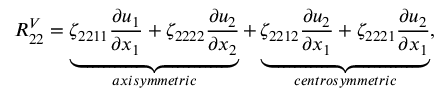Convert formula to latex. <formula><loc_0><loc_0><loc_500><loc_500>R _ { 2 2 } ^ { V } = \underbrace { \zeta _ { 2 2 1 1 } \frac { \partial u _ { 1 } } { \partial x _ { 1 } } + \zeta _ { 2 2 2 2 } \frac { \partial u _ { 2 } } { \partial x _ { 2 } } } _ { a x i s y m m e t r i c } + \underbrace { \zeta _ { 2 2 1 2 } \frac { \partial u _ { 2 } } { \partial x _ { 1 } } + \zeta _ { 2 2 2 1 } \frac { \partial u _ { 2 } } { \partial x _ { 1 } } } _ { c e n t r o s y m m e t r i c } ,</formula> 